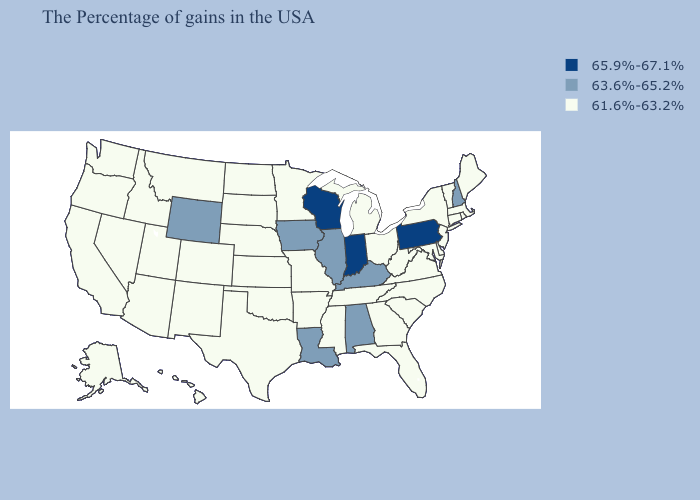Does Iowa have the lowest value in the MidWest?
Concise answer only. No. Does Wyoming have the lowest value in the West?
Be succinct. No. What is the value of Nebraska?
Give a very brief answer. 61.6%-63.2%. Name the states that have a value in the range 63.6%-65.2%?
Give a very brief answer. New Hampshire, Kentucky, Alabama, Illinois, Louisiana, Iowa, Wyoming. Among the states that border Iowa , does South Dakota have the lowest value?
Give a very brief answer. Yes. What is the value of Utah?
Be succinct. 61.6%-63.2%. Name the states that have a value in the range 61.6%-63.2%?
Write a very short answer. Maine, Massachusetts, Rhode Island, Vermont, Connecticut, New York, New Jersey, Delaware, Maryland, Virginia, North Carolina, South Carolina, West Virginia, Ohio, Florida, Georgia, Michigan, Tennessee, Mississippi, Missouri, Arkansas, Minnesota, Kansas, Nebraska, Oklahoma, Texas, South Dakota, North Dakota, Colorado, New Mexico, Utah, Montana, Arizona, Idaho, Nevada, California, Washington, Oregon, Alaska, Hawaii. Which states have the highest value in the USA?
Answer briefly. Pennsylvania, Indiana, Wisconsin. Among the states that border West Virginia , which have the highest value?
Write a very short answer. Pennsylvania. Does the map have missing data?
Write a very short answer. No. Does the first symbol in the legend represent the smallest category?
Concise answer only. No. Which states have the lowest value in the USA?
Write a very short answer. Maine, Massachusetts, Rhode Island, Vermont, Connecticut, New York, New Jersey, Delaware, Maryland, Virginia, North Carolina, South Carolina, West Virginia, Ohio, Florida, Georgia, Michigan, Tennessee, Mississippi, Missouri, Arkansas, Minnesota, Kansas, Nebraska, Oklahoma, Texas, South Dakota, North Dakota, Colorado, New Mexico, Utah, Montana, Arizona, Idaho, Nevada, California, Washington, Oregon, Alaska, Hawaii. Is the legend a continuous bar?
Be succinct. No. What is the lowest value in the USA?
Write a very short answer. 61.6%-63.2%. 